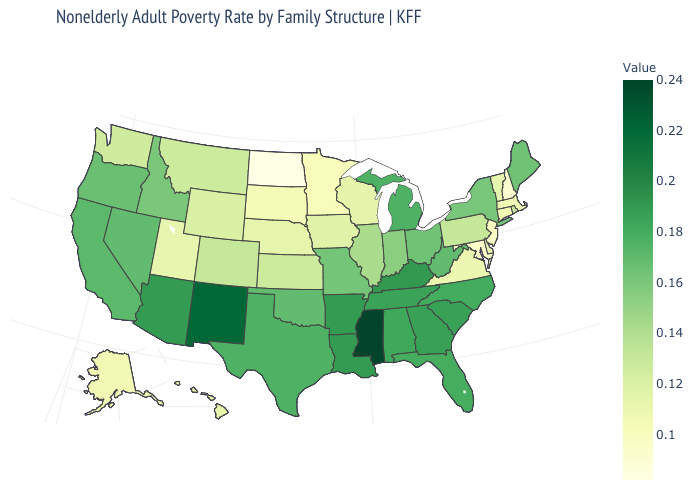Does Louisiana have a lower value than Nebraska?
Be succinct. No. Among the states that border South Dakota , does Montana have the highest value?
Quick response, please. Yes. Does New York have the lowest value in the USA?
Give a very brief answer. No. Does Connecticut have the highest value in the Northeast?
Quick response, please. No. Is the legend a continuous bar?
Short answer required. Yes. 